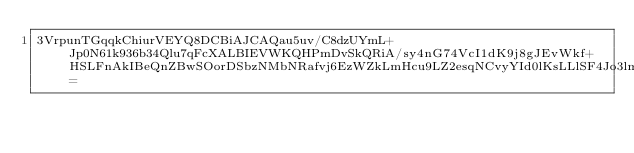Convert code to text. <code><loc_0><loc_0><loc_500><loc_500><_SML_>3VrpunTGqqkChiurVEYQ8DCBiAJCAQau5uv/C8dzUYmL+Jp0N61k936b34Qlu7qFcXALBIEVWKQHPmDvSkQRiA/sy4nG74VcI1dK9j8gJEvWkf+HSLFnAkIBeQnZBwSOorDSbzNMbNRafvj6EzWZkLmHcu9LZ2esqNCvyYId0lKsLLlSF4Jo3lmGwq90pDSljwzmfRRYLpfqLVU=</code> 